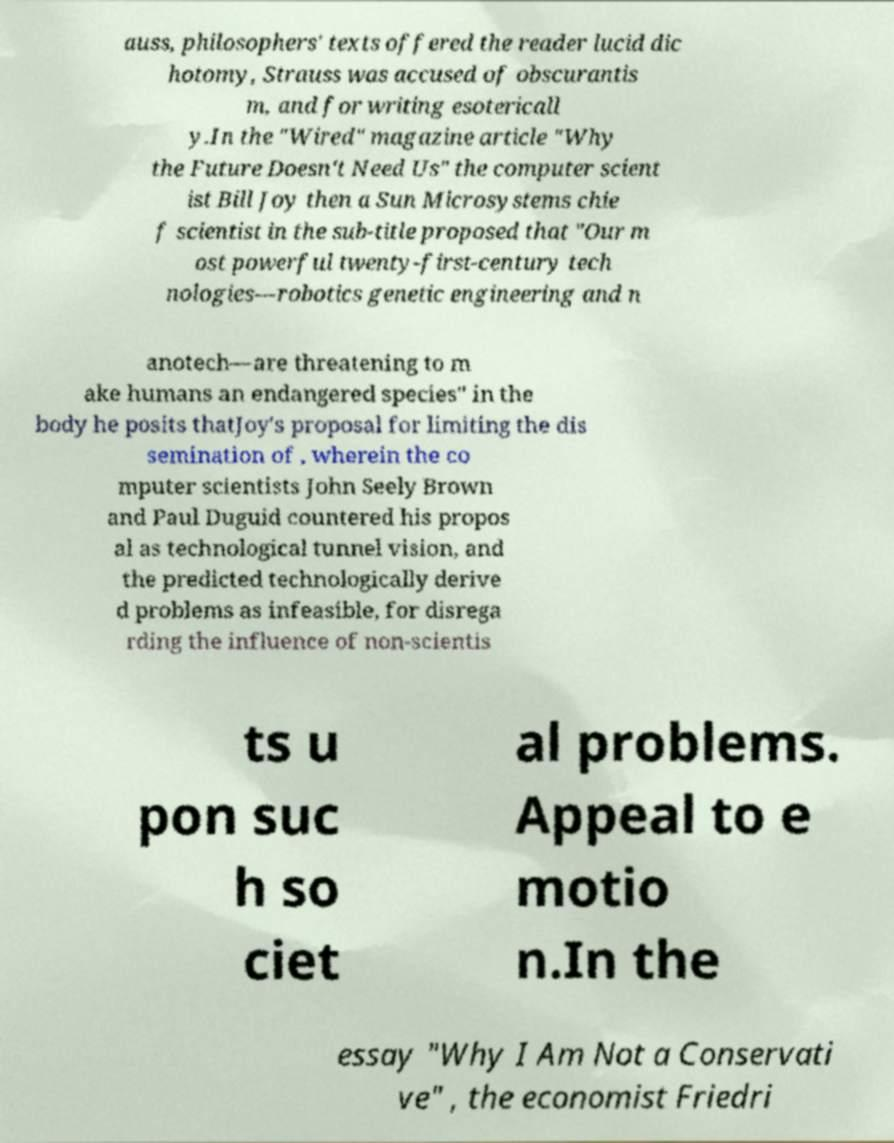There's text embedded in this image that I need extracted. Can you transcribe it verbatim? auss, philosophers' texts offered the reader lucid dic hotomy, Strauss was accused of obscurantis m, and for writing esotericall y.In the "Wired" magazine article "Why the Future Doesn't Need Us" the computer scient ist Bill Joy then a Sun Microsystems chie f scientist in the sub-title proposed that "Our m ost powerful twenty-first-century tech nologies—robotics genetic engineering and n anotech—are threatening to m ake humans an endangered species" in the body he posits thatJoy's proposal for limiting the dis semination of , wherein the co mputer scientists John Seely Brown and Paul Duguid countered his propos al as technological tunnel vision, and the predicted technologically derive d problems as infeasible, for disrega rding the influence of non-scientis ts u pon suc h so ciet al problems. Appeal to e motio n.In the essay "Why I Am Not a Conservati ve" , the economist Friedri 